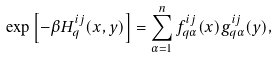Convert formula to latex. <formula><loc_0><loc_0><loc_500><loc_500>\exp \left [ - \beta H _ { q } ^ { i j } ( x , y ) \right ] = \sum _ { \alpha = 1 } ^ { n } f _ { q \alpha } ^ { i j } ( x ) g _ { q \alpha } ^ { i j } ( y ) ,</formula> 